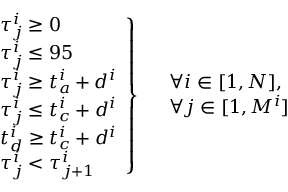Convert formula to latex. <formula><loc_0><loc_0><loc_500><loc_500>\begin{array} { r l } & { \tau _ { j } ^ { i } \geq 0 } \\ & { \tau _ { j } ^ { i } \leq 9 5 } \\ & { \tau _ { j } ^ { i } \geq t _ { a } ^ { i } + d ^ { i } } \\ & { \tau _ { j } ^ { i } \leq t _ { c } ^ { i } + d ^ { i } } \\ & { t _ { d } ^ { i } \geq t _ { c } ^ { i } + d ^ { i } } \\ & { \tau _ { j } ^ { i } < \tau _ { j + 1 } ^ { i } } \end{array} \right \} \begin{array} { r l } & { \forall i \in [ 1 , N ] , } \\ & { \forall j \in [ 1 , M ^ { i } ] } \end{array}</formula> 